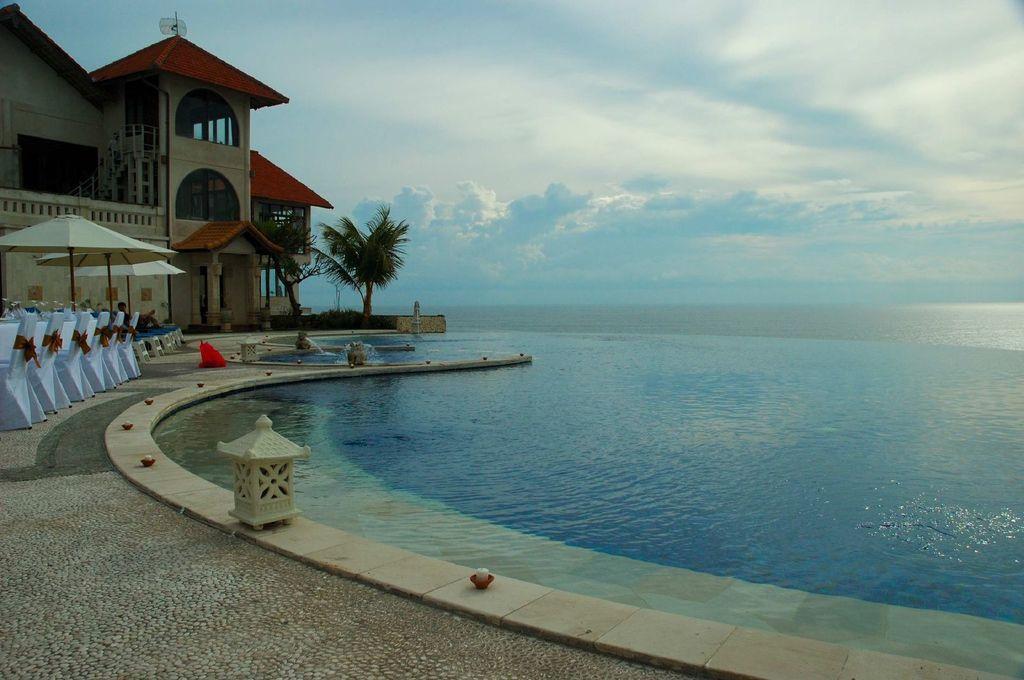How would you summarize this image in a sentence or two? In this image I can see a building,stairs,trees,few chairs,tents and pool. The sky is in blue and white color. 